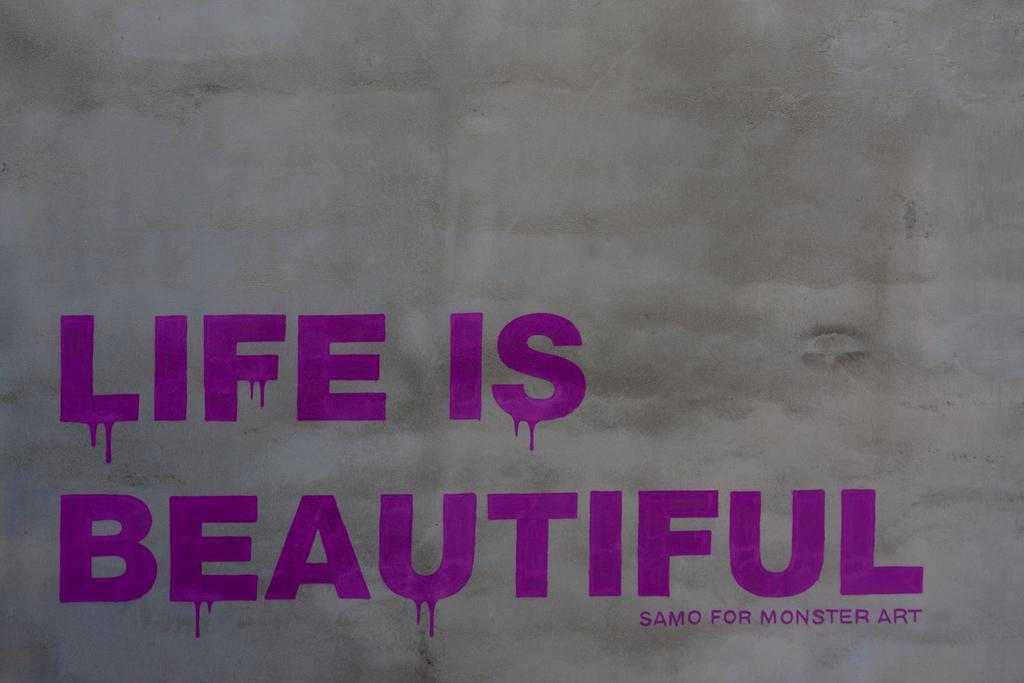<image>
Render a clear and concise summary of the photo. A gray sign that says life is beautiful in purple 